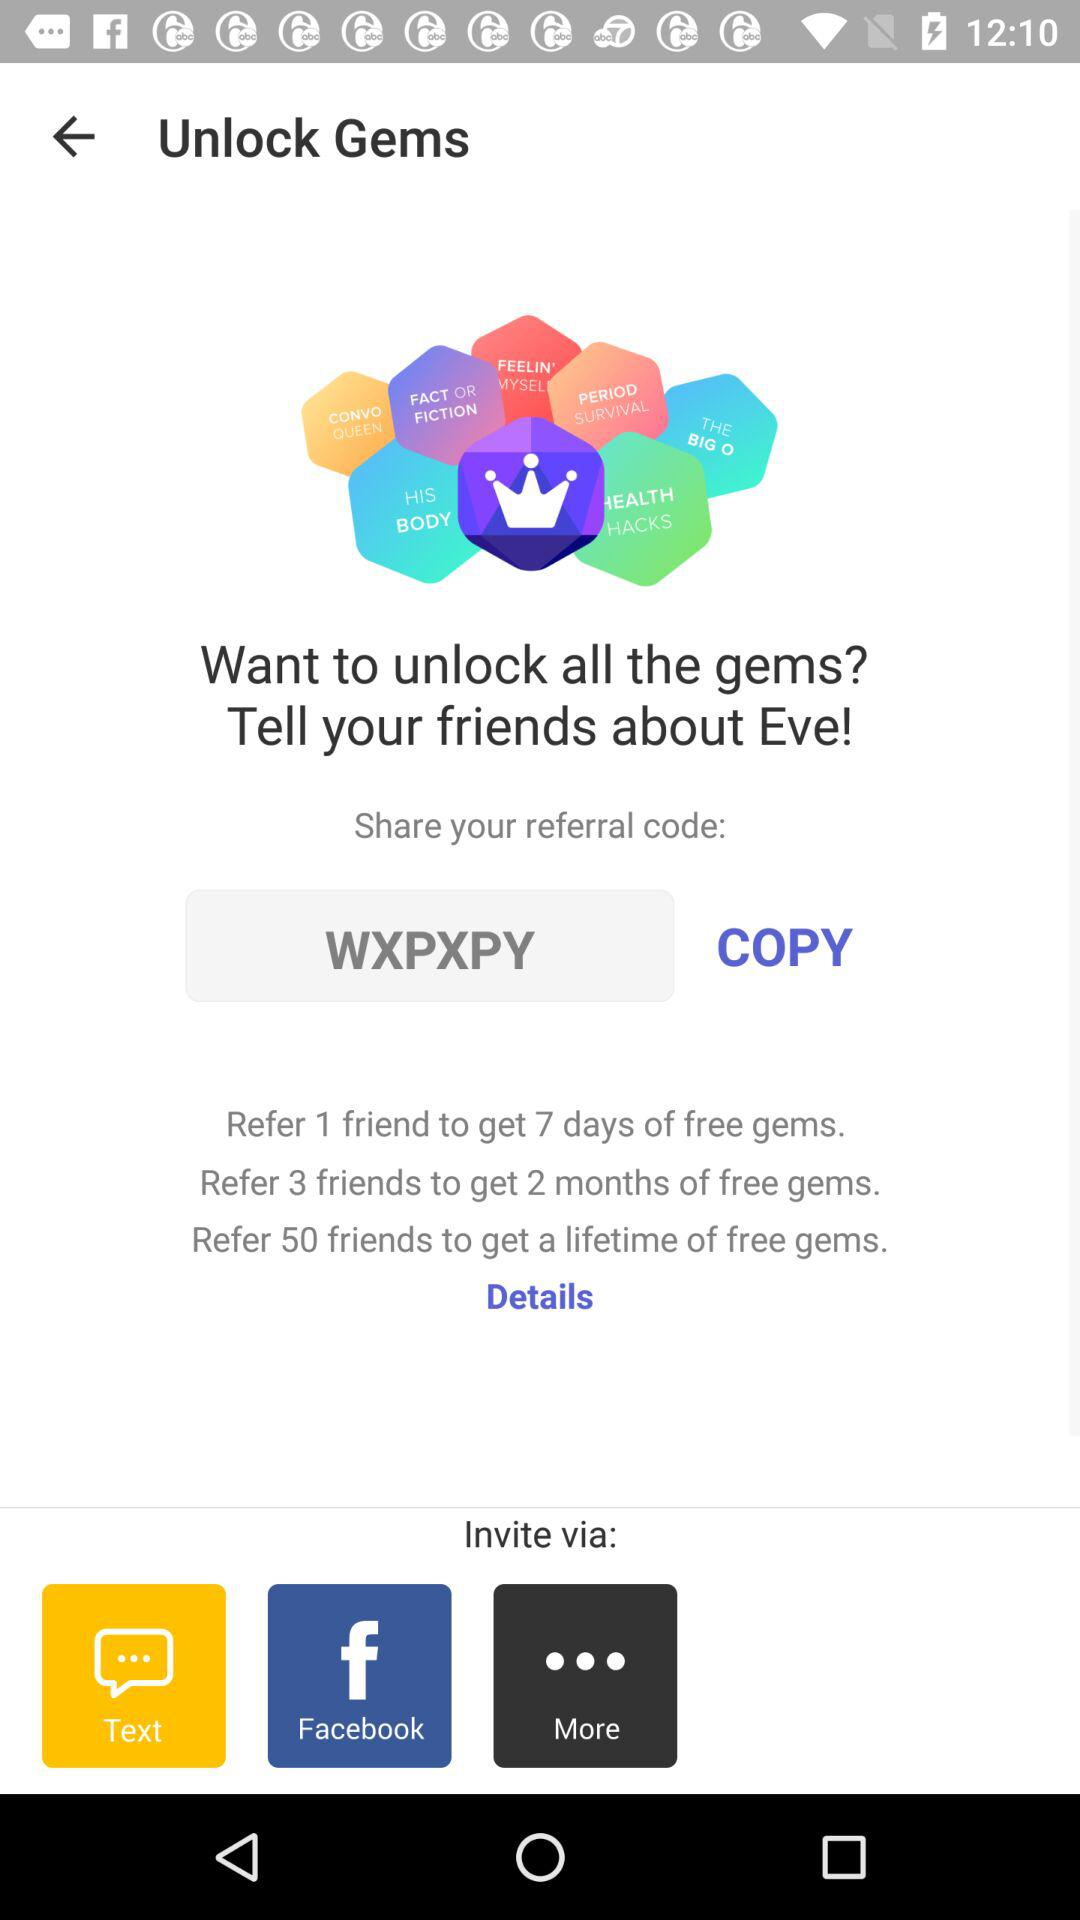How many friends do you need to refer to get a lifetime of free gems?
Answer the question using a single word or phrase. 50 